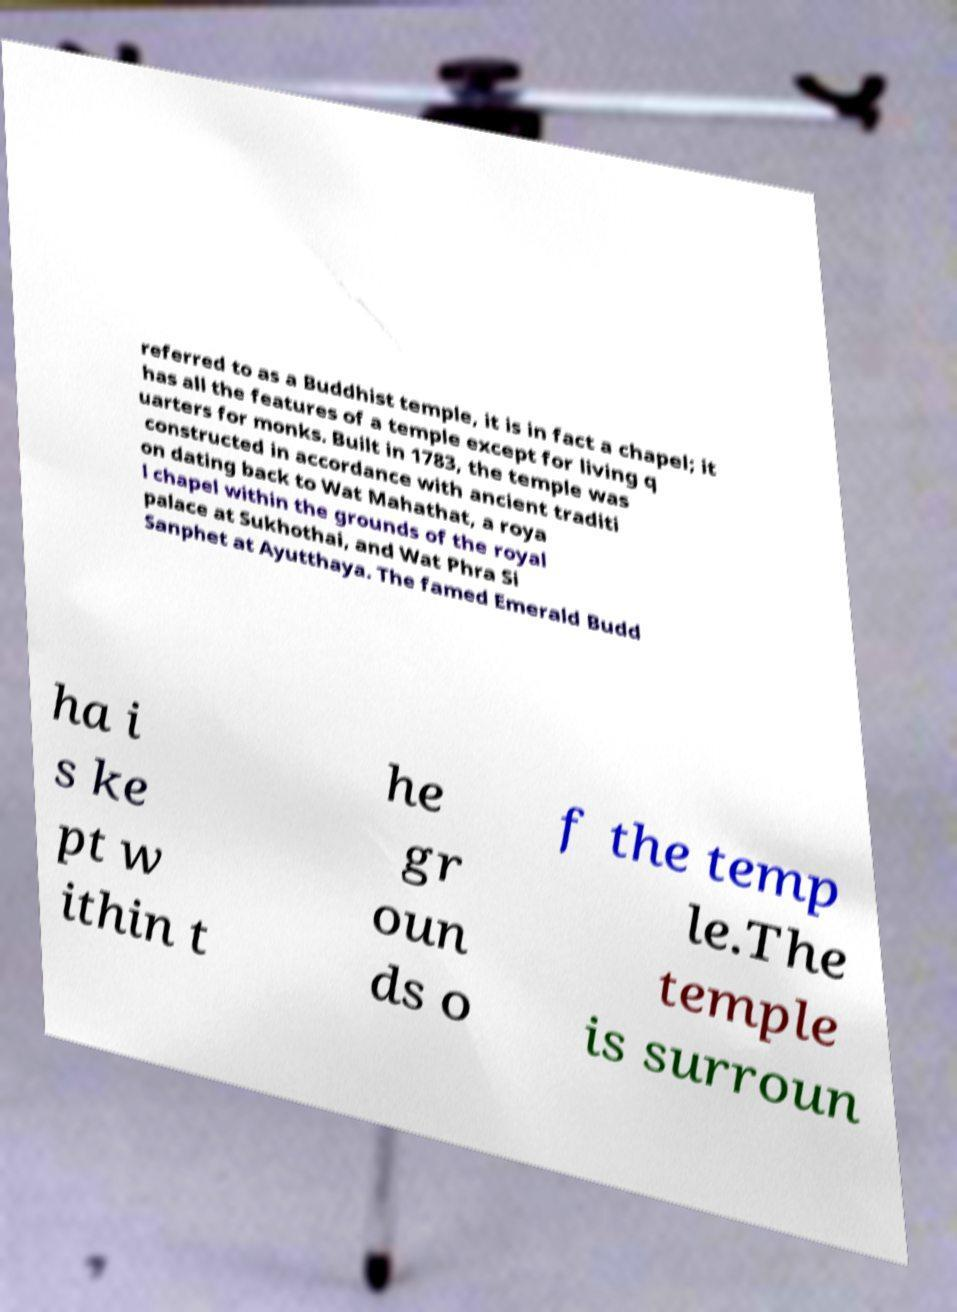For documentation purposes, I need the text within this image transcribed. Could you provide that? referred to as a Buddhist temple, it is in fact a chapel; it has all the features of a temple except for living q uarters for monks. Built in 1783, the temple was constructed in accordance with ancient traditi on dating back to Wat Mahathat, a roya l chapel within the grounds of the royal palace at Sukhothai, and Wat Phra Si Sanphet at Ayutthaya. The famed Emerald Budd ha i s ke pt w ithin t he gr oun ds o f the temp le.The temple is surroun 